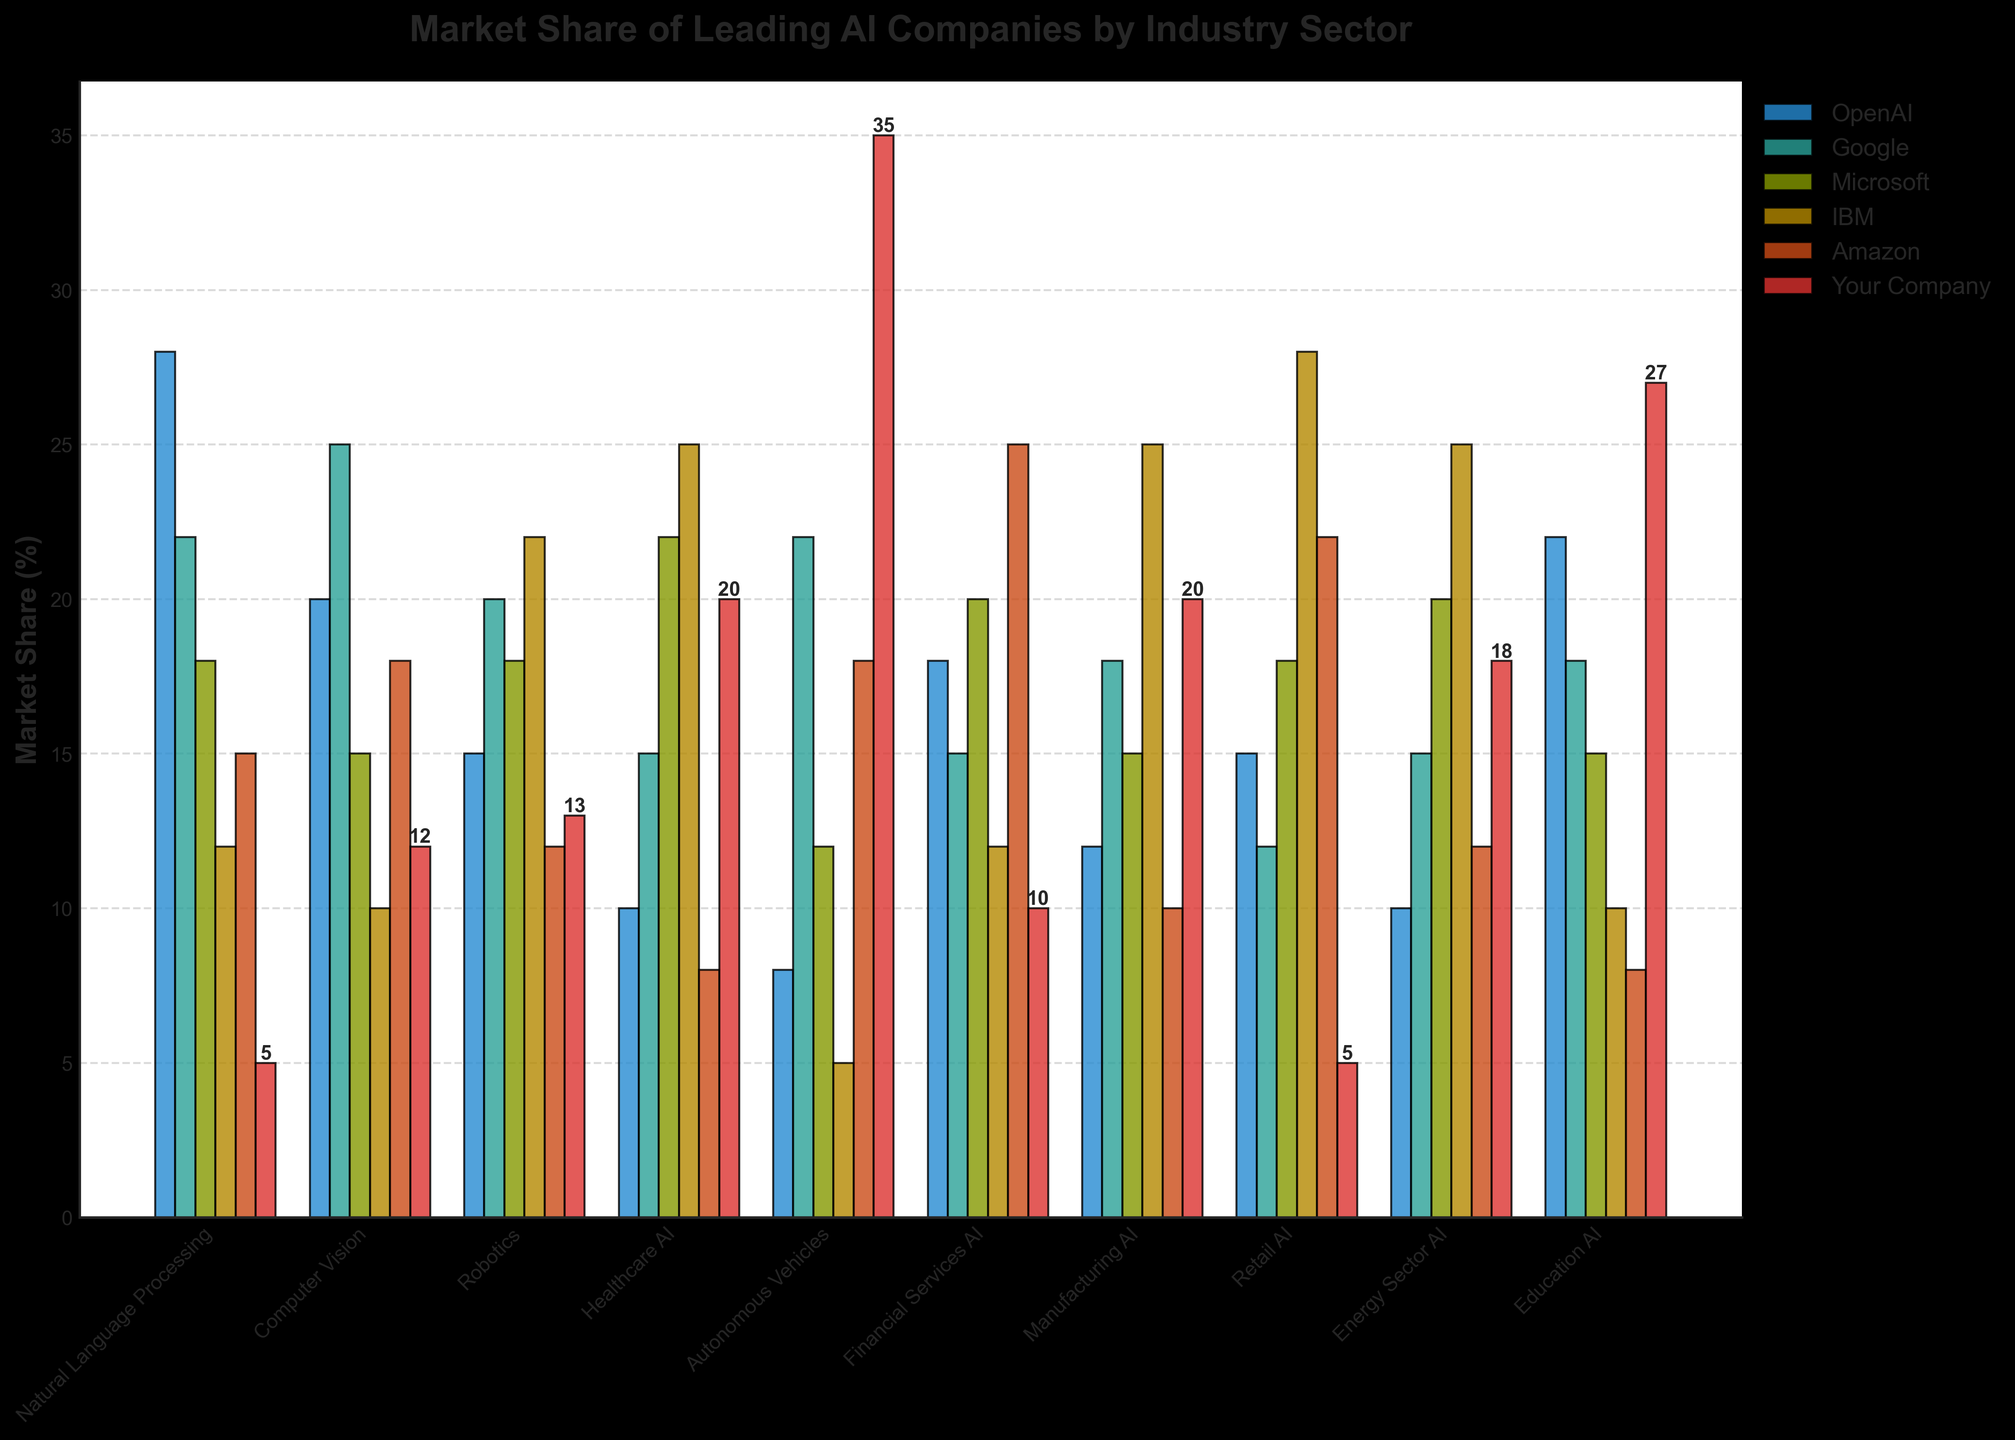Which company has the highest market share in the Education AI sector? In the Education AI sector, the bar for "Your Company" is visually the tallest, indicating it has the highest market share.
Answer: Your Company Which company has the lowest market share in the Robotics sector? In the Robotics sector, IBM's bar is the shortest, indicating it has the lowest market share.
Answer: IBM What is the total market share held by OpenAI in all sectors? Sum OpenAI's market shares across all sectors: 28 + 20 + 15 + 10 + 8 + 18 + 12 + 15 + 10 + 22 = 158.
Answer: 158 Compare the market shares of "Google" and "Amazon" in the Computer Vision sector. Which one is higher? Examining the bars for Google and Amazon in the Computer Vision sector, Google's bar is slightly taller than Amazon's bar.
Answer: Google Calculate the average market share of "Your Company" across all sectors. Sum the market shares of "Your Company" in all sectors: 5 + 12 + 13 + 20 + 35 + 10 + 20 + 5 + 18 + 27 = 165. Divide by the number of sectors: 165 / 10 = 16.5.
Answer: 16.5 Which sector has the highest market share for IBM, and what is the value? The tallest bar for IBM is in the Manufacturing AI sector, indicating the highest market share of 25%.
Answer: Manufacturing AI, 25 How does the market share of Microsoft in Financial Services AI compare to its market share in Retail AI? In Financial Services AI, Microsoft's bar is taller than in Retail AI, with values of 20% in Financial Services AI and 18% in Retail AI.
Answer: Higher in Financial Services AI Find the sectors where "Your Company" has a higher market share than OpenAI. Compare the bars for "Your Company" and OpenAI in each sector. "Your Company" has a higher market share in Autonomous Vehicles (35% vs 8%), Healthcare AI (20% vs 10%), Manufacturing AI (20% vs 12%), and Education AI (27% vs 22%).
Answer: Autonomous Vehicles, Healthcare AI, Manufacturing AI, Education AI What’s the difference in market share between OpenAI and IBM in the Manufacturing AI sector? Subtract IBM's market share from OpenAI's in the Manufacturing AI sector: 12 - 25 = -13. However, IBM's market share is higher by 13 percentage points.
Answer: 13 (IBM is higher) 